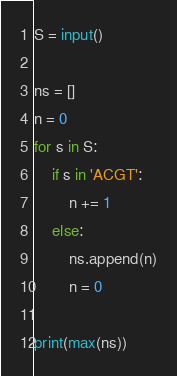Convert code to text. <code><loc_0><loc_0><loc_500><loc_500><_Python_>S = input()

ns = []
n = 0
for s in S:
    if s in 'ACGT':
        n += 1
    else:
        ns.append(n)
        n = 0

print(max(ns))</code> 